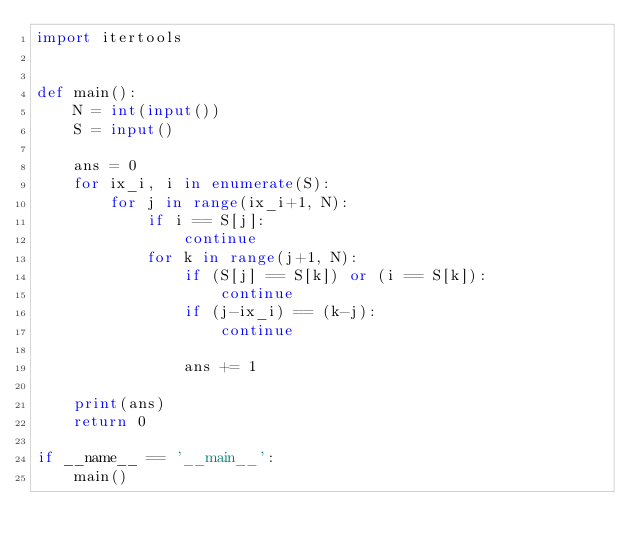Convert code to text. <code><loc_0><loc_0><loc_500><loc_500><_Python_>import itertools


def main():
    N = int(input())
    S = input()

    ans = 0
    for ix_i, i in enumerate(S):
        for j in range(ix_i+1, N):
            if i == S[j]:
                continue
            for k in range(j+1, N):
                if (S[j] == S[k]) or (i == S[k]):
                    continue
                if (j-ix_i) == (k-j):
                    continue

                ans += 1

    print(ans)
    return 0

if __name__ == '__main__':
    main()</code> 